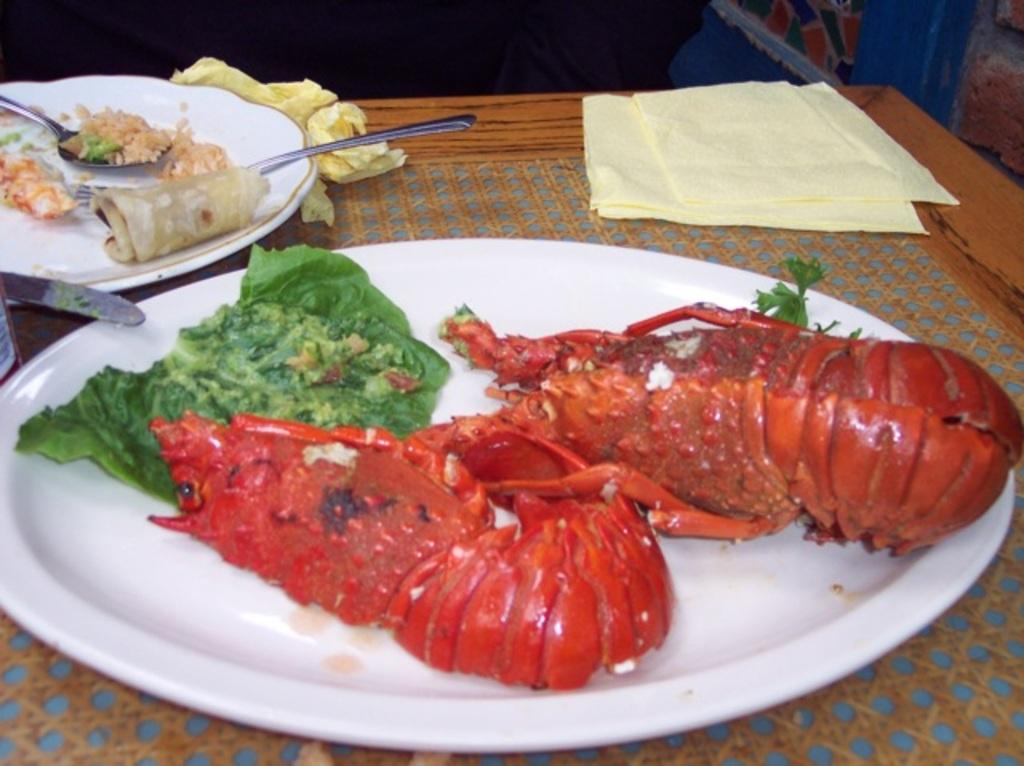What piece of furniture is present in the image? There is a table in the image. What items are on the table? There are plates, knives, forks, spoons, lobsters, and napkins on the table. What type of food can be seen on the table? There is food on the table, specifically lobsters. What type of frame is visible around the lobsters on the table? There is no frame visible around the lobsters on the table; they are simply placed on the table. What arm is used to hold the spoon while eating the oatmeal on the table? There is no oatmeal present in the image, and therefore no arm is used to hold a spoon for eating it. 